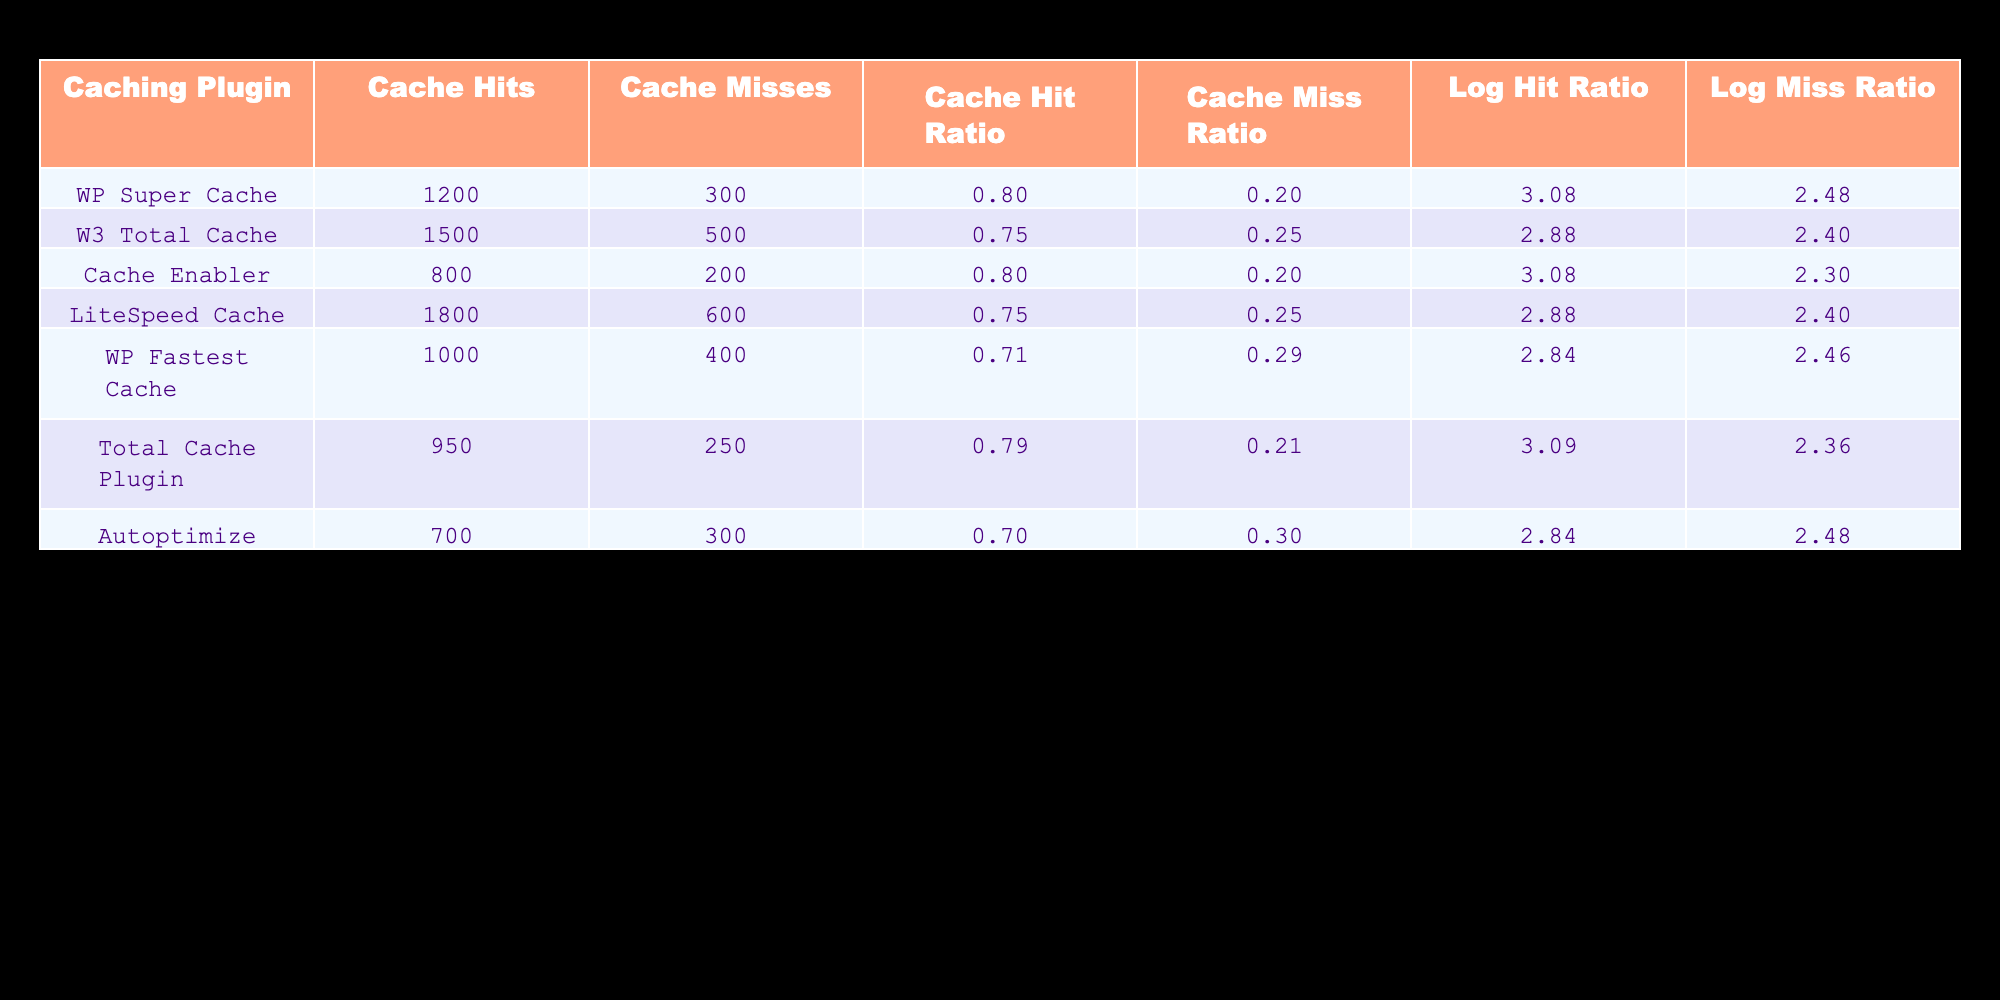What is the Cache Hit Ratio for WP Super Cache? The table shows that the Cache Hit Ratio for WP Super Cache is listed directly under the appropriate column. Referring to the row for WP Super Cache, the Cache Hit Ratio is 0.80.
Answer: 0.80 Which caching plugin has the highest number of Cache Misses? By inspecting the column for Cache Misses, we see that LiteSpeed Cache has 600 Cache Misses, which is the highest value compared to the other plugins listed.
Answer: LiteSpeed Cache What is the average Cache Hit Ratio for all the plugins? To find the average, we add all the Cache Hit Ratios together: 0.80 + 0.75 + 0.80 + 0.75 + 0.71 + 0.79 + 0.70 = 5.30. Then, we divide by the number of plugins, which is 7: 5.30 / 7 = 0.7571, rounding to 0.76 for simplicity.
Answer: 0.76 Is the Cache Miss Ratio for Cache Enabler equal to the Cache Miss Ratio for WP Fastest Cache? Looking at the table, the Cache Miss Ratio for Cache Enabler is 0.20, and for WP Fastest Cache, it is 0.29. Since these two values are not equal, the answer is no.
Answer: No What is the difference in Cache Hits between W3 Total Cache and Total Cache Plugin? The Cache Hits for W3 Total Cache is 1500 and for Total Cache Plugin, it is 950. To find the difference, we subtract: 1500 - 950 = 550.
Answer: 550 Which caching plugins have a Cache Hit Ratio greater than 0.75? Reviewing the Cache Hit Ratios in the table, we see that WP Super Cache (0.80), Cache Enabler (0.80), and Total Cache Plugin (0.79) have ratios greater than 0.75.
Answer: WP Super Cache, Cache Enabler, Total Cache Plugin Is the Log Miss Ratio for Autoptimize less than that of W3 Total Cache? According to the table, the Log Miss Ratio for Autoptimize is 2.48, while for W3 Total Cache it is 2.40. Since 2.48 is not less than 2.40, the answer is no.
Answer: No What is the total number of Cache Hits across all the plugins? We total the Cache Hits: 1200 + 1500 + 800 + 1800 + 1000 + 950 + 700 = 6950 Cache Hits.
Answer: 6950 What is the average Log Miss Ratio for all the caching plugins? To calculate the average Log Miss Ratio, we sum the values: 2.48 + 2.40 + 2.30 + 2.40 + 2.46 + 2.36 + 2.48 = 17.88. We then divide by the number of plugins (7): 17.88 / 7 = 2.554, which can be rounded to 2.55.
Answer: 2.55 